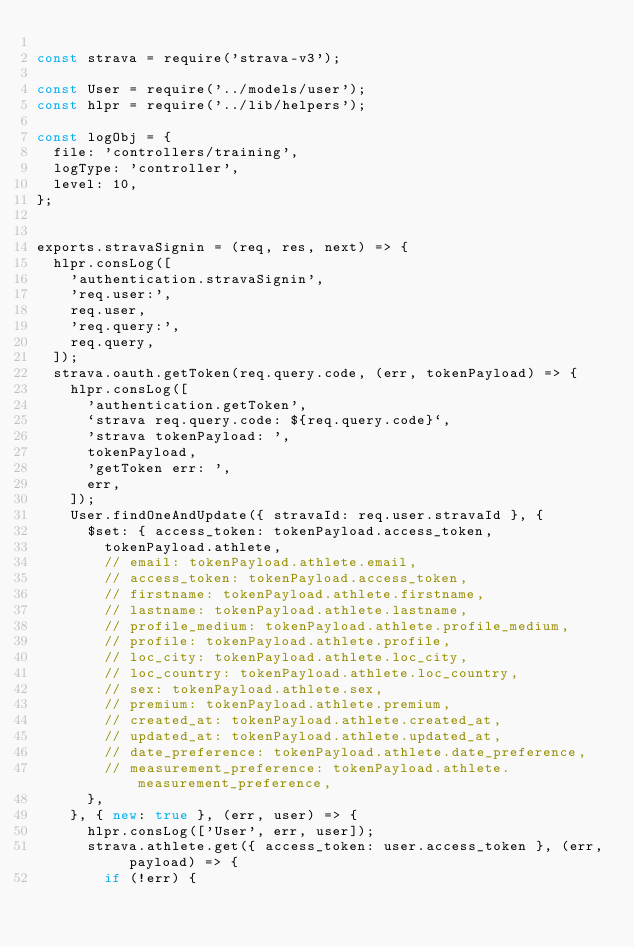<code> <loc_0><loc_0><loc_500><loc_500><_JavaScript_>
const strava = require('strava-v3');

const User = require('../models/user');
const hlpr = require('../lib/helpers');

const logObj = {
  file: 'controllers/training',
  logType: 'controller',
  level: 10,
};


exports.stravaSignin = (req, res, next) => {
  hlpr.consLog([
    'authentication.stravaSignin',
    'req.user:',
    req.user,
    'req.query:',
    req.query,
  ]);
  strava.oauth.getToken(req.query.code, (err, tokenPayload) => {
    hlpr.consLog([
      'authentication.getToken',
      `strava req.query.code: ${req.query.code}`,
      'strava tokenPayload: ',
      tokenPayload,
      'getToken err: ',
      err,
    ]);
    User.findOneAndUpdate({ stravaId: req.user.stravaId }, {
      $set: { access_token: tokenPayload.access_token,
        tokenPayload.athlete,
        // email: tokenPayload.athlete.email,
        // access_token: tokenPayload.access_token,
        // firstname: tokenPayload.athlete.firstname,
        // lastname: tokenPayload.athlete.lastname,
        // profile_medium: tokenPayload.athlete.profile_medium,
        // profile: tokenPayload.athlete.profile,
        // loc_city: tokenPayload.athlete.loc_city,
        // loc_country: tokenPayload.athlete.loc_country,
        // sex: tokenPayload.athlete.sex,
        // premium: tokenPayload.athlete.premium,
        // created_at: tokenPayload.athlete.created_at,
        // updated_at: tokenPayload.athlete.updated_at,
        // date_preference: tokenPayload.athlete.date_preference,
        // measurement_preference: tokenPayload.athlete.measurement_preference,
      },
    }, { new: true }, (err, user) => {
      hlpr.consLog(['User', err, user]);
      strava.athlete.get({ access_token: user.access_token }, (err, payload) => {
        if (!err) {</code> 